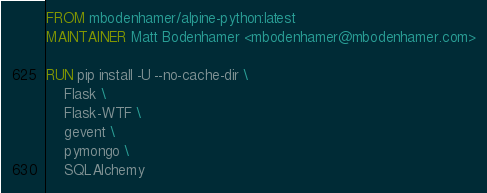<code> <loc_0><loc_0><loc_500><loc_500><_Dockerfile_>FROM mbodenhamer/alpine-python:latest
MAINTAINER Matt Bodenhamer <mbodenhamer@mbodenhamer.com>

RUN pip install -U --no-cache-dir \
    Flask \
    Flask-WTF \
    gevent \
    pymongo \
    SQLAlchemy
</code> 